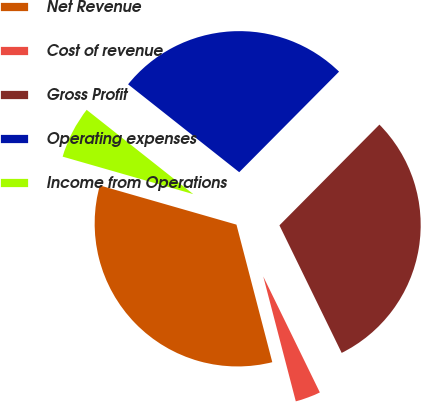Convert chart to OTSL. <chart><loc_0><loc_0><loc_500><loc_500><pie_chart><fcel>Net Revenue<fcel>Cost of revenue<fcel>Gross Profit<fcel>Operating expenses<fcel>Income from Operations<nl><fcel>33.5%<fcel>3.17%<fcel>30.33%<fcel>26.79%<fcel>6.2%<nl></chart> 